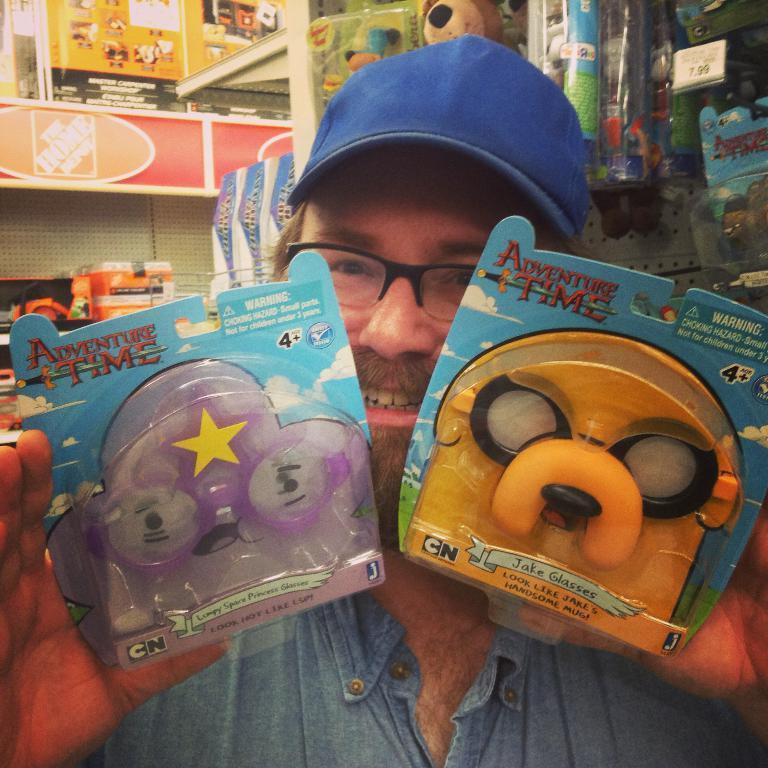Describe this image in one or two sentences. In this image, we can see a person wearing glasses and a cap and holding some objects. In the background, there are toys and we can see boards and some other objects. 